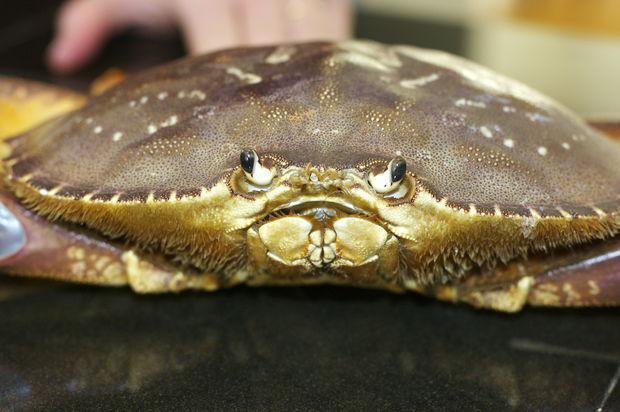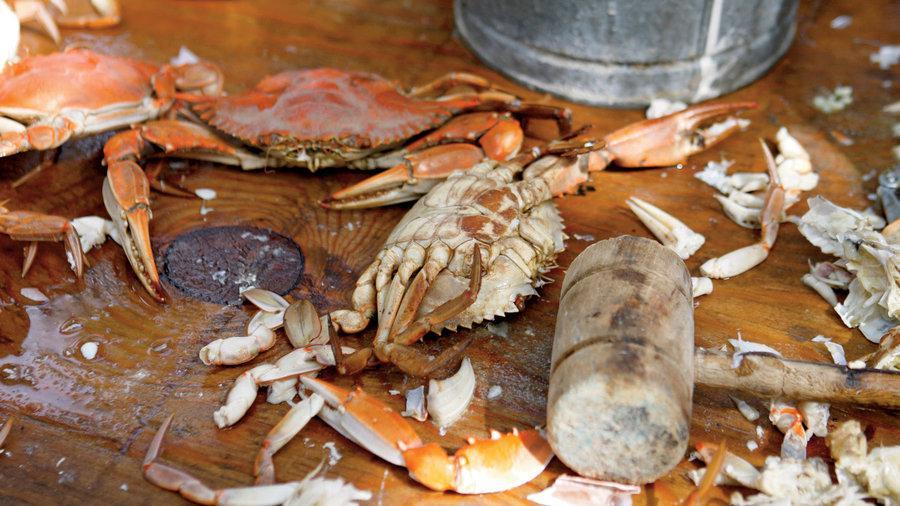The first image is the image on the left, the second image is the image on the right. Evaluate the accuracy of this statement regarding the images: "Each image includes a crab with a purplish shell looking toward the camera.". Is it true? Answer yes or no. No. 